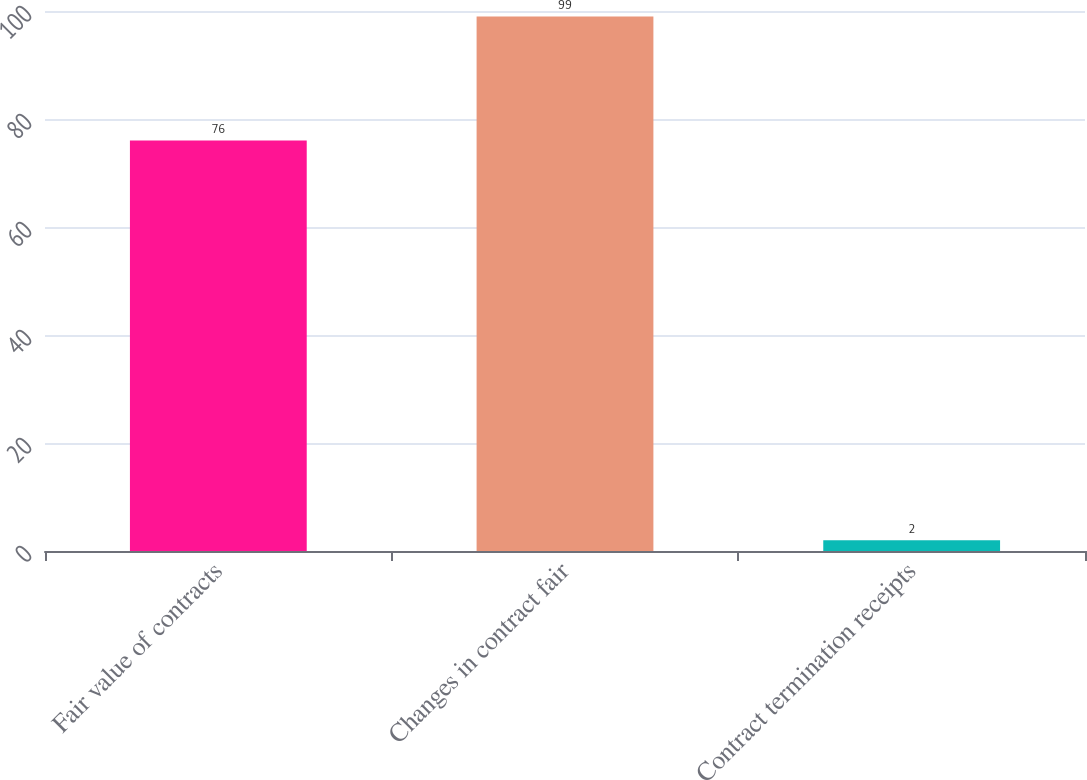Convert chart to OTSL. <chart><loc_0><loc_0><loc_500><loc_500><bar_chart><fcel>Fair value of contracts<fcel>Changes in contract fair<fcel>Contract termination receipts<nl><fcel>76<fcel>99<fcel>2<nl></chart> 